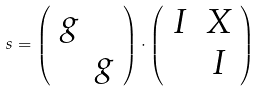Convert formula to latex. <formula><loc_0><loc_0><loc_500><loc_500>s = \left ( \begin{array} { c c } g \\ & g \end{array} \right ) \cdot \left ( \begin{array} { c c } I & X \\ & I \end{array} \right )</formula> 